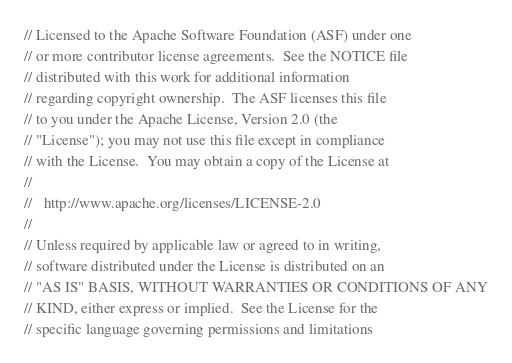<code> <loc_0><loc_0><loc_500><loc_500><_C++_>// Licensed to the Apache Software Foundation (ASF) under one
// or more contributor license agreements.  See the NOTICE file
// distributed with this work for additional information
// regarding copyright ownership.  The ASF licenses this file
// to you under the Apache License, Version 2.0 (the
// "License"); you may not use this file except in compliance
// with the License.  You may obtain a copy of the License at
//
//   http://www.apache.org/licenses/LICENSE-2.0
//
// Unless required by applicable law or agreed to in writing,
// software distributed under the License is distributed on an
// "AS IS" BASIS, WITHOUT WARRANTIES OR CONDITIONS OF ANY
// KIND, either express or implied.  See the License for the
// specific language governing permissions and limitations</code> 